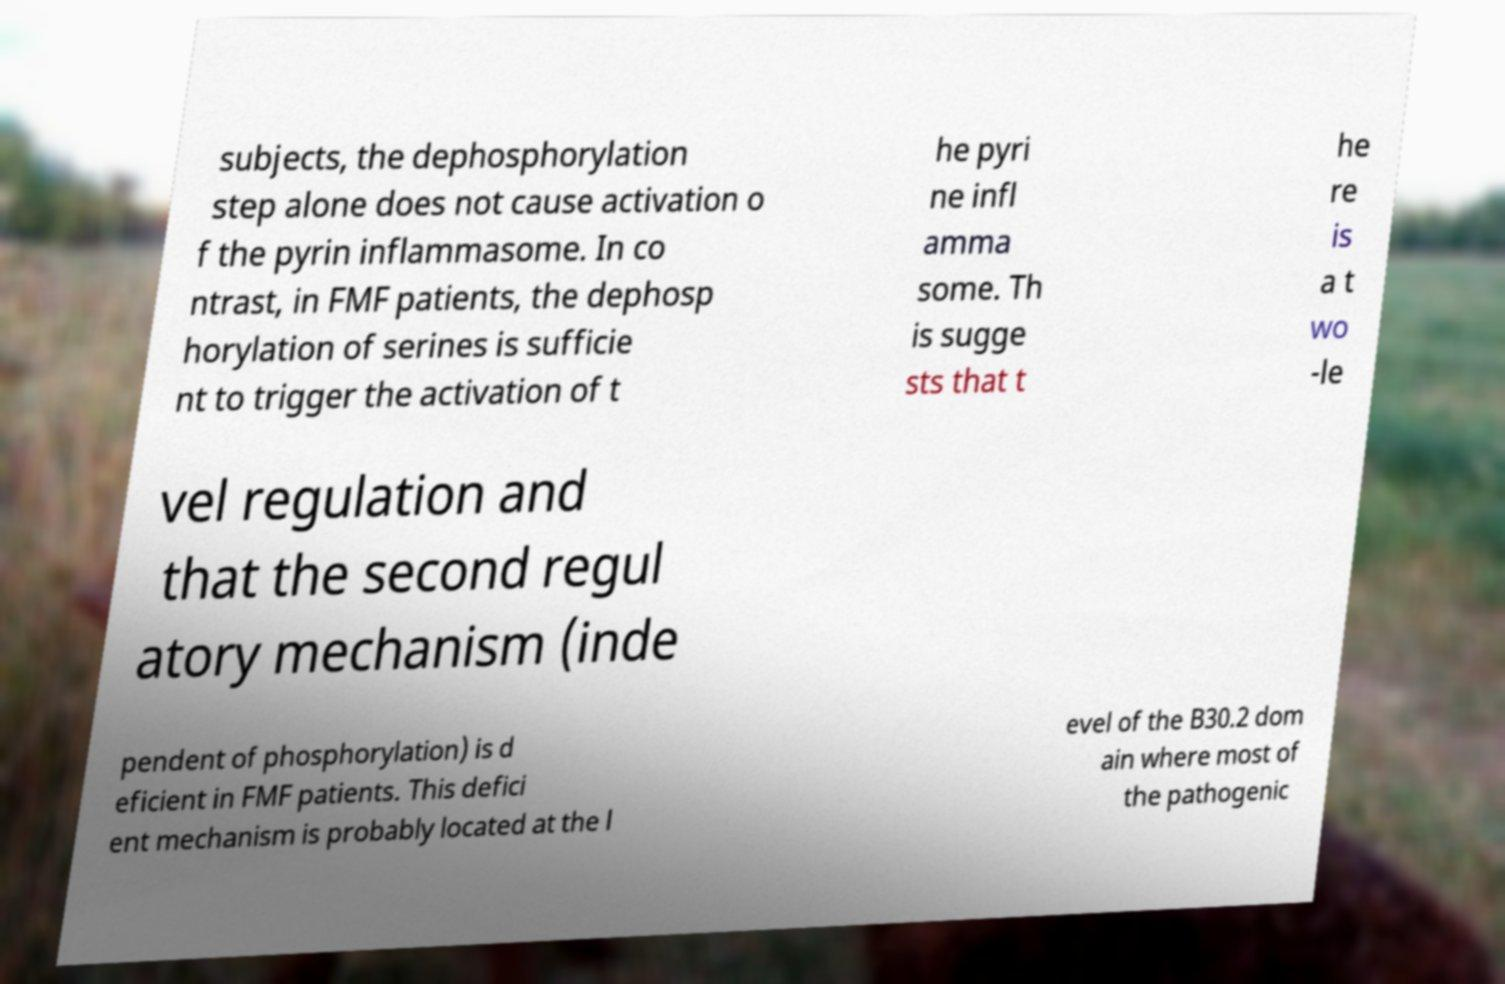What messages or text are displayed in this image? I need them in a readable, typed format. subjects, the dephosphorylation step alone does not cause activation o f the pyrin inflammasome. In co ntrast, in FMF patients, the dephosp horylation of serines is sufficie nt to trigger the activation of t he pyri ne infl amma some. Th is sugge sts that t he re is a t wo -le vel regulation and that the second regul atory mechanism (inde pendent of phosphorylation) is d eficient in FMF patients. This defici ent mechanism is probably located at the l evel of the B30.2 dom ain where most of the pathogenic 